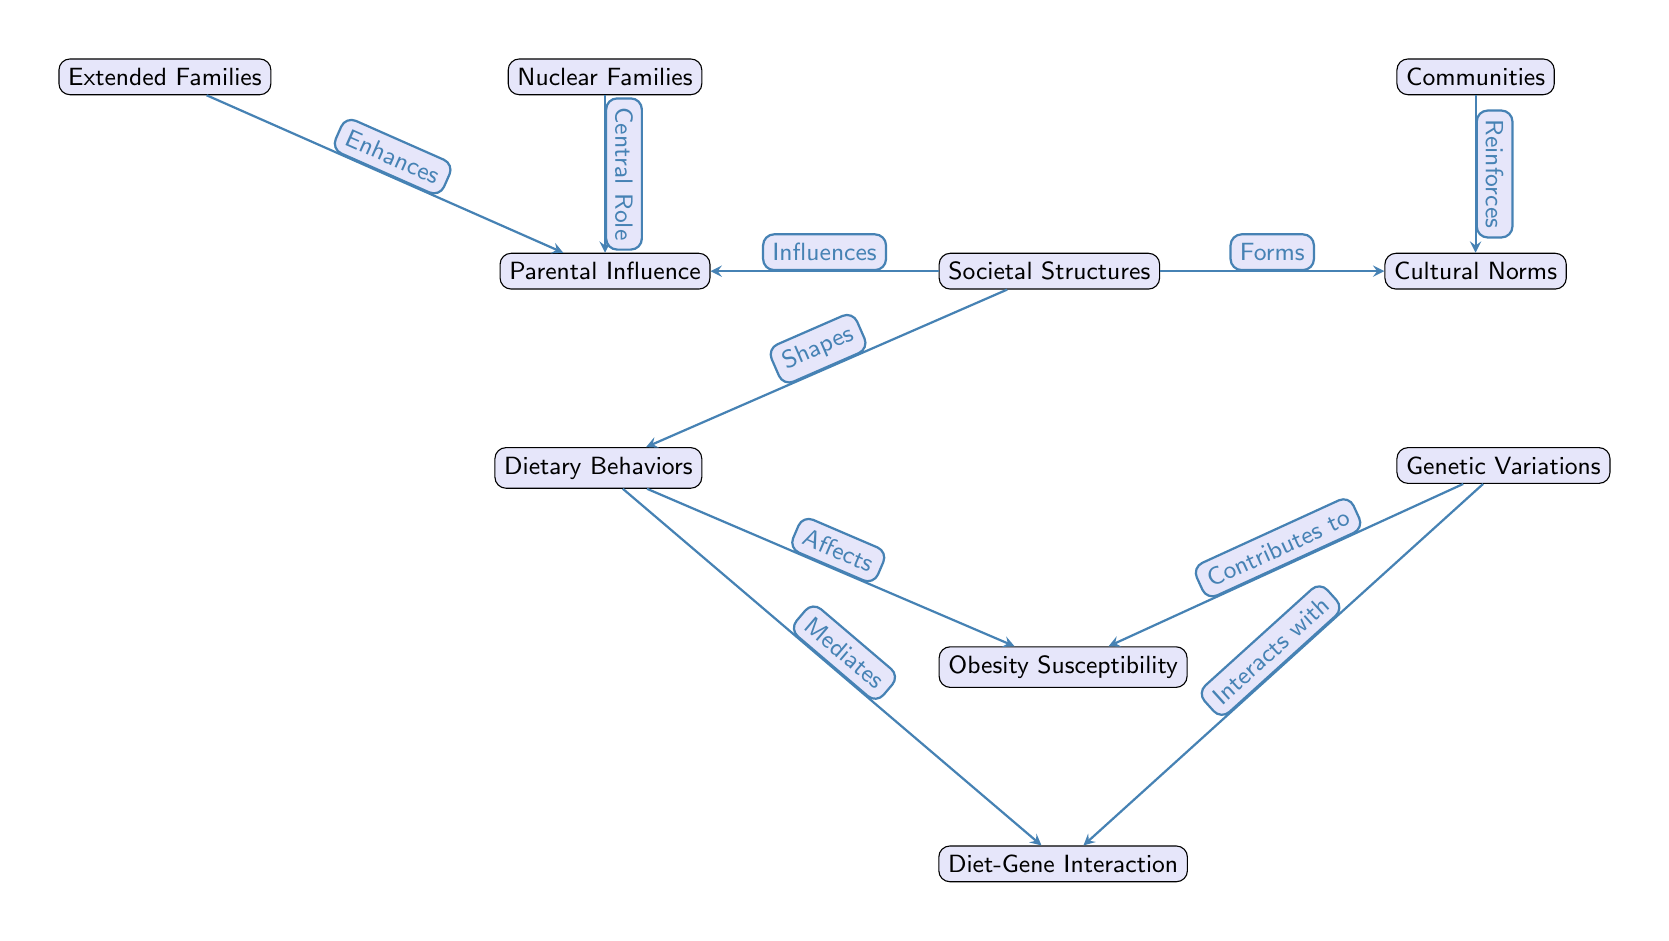What are the two main components of society represented in the diagram? The diagram includes "Dietary Behaviors" and "Genetic Variations" as the two primary components that influence societal structures.
Answer: Dietary Behaviors, Genetic Variations How many nodes are there in the diagram? By counting each labeled box, there are a total of ten nodes: Societal Structures, Dietary Behaviors, Genetic Variations, Obesity Susceptibility, Nuclear Families, Extended Families, Communities, Parental Influence, Cultural Norms, Diet-Gene Interaction.
Answer: 10 What does "Cultural Norms" reinforce in the diagram? "Cultural Norms" reinforces the influence of "Communities" on the dietary behaviors and genetic susceptibility to obesity, highlighting the social context in which these interactions occur.
Answer: Cultural Norms reinforces Communities Which node has arrows directed towards "Obesity Susceptibility"? The nodes "Dietary Behaviors" and "Genetic Variations" both have arrows pointing to "Obesity Susceptibility," indicating that both dietary habits and genetic factors contribute to the risk of obesity.
Answer: Dietary Behaviors, Genetic Variations How does "Parental Influence" relate to "Nuclear Families"? The node "Nuclear Families" has a direct relationship labeled as "Central Role" with "Parental Influence," signifying the important part that families play in shaping children's dietary habits and genetic factors leading to obesity susceptibility.
Answer: Central Role What interaction is mediated by "Dietary Behaviors"? The arrow from "Dietary Behaviors" leading to "Diet-Gene Interaction" indicates that dietary behaviors mediate how genetic variations affect obesity susceptibility, suggesting a complex interplay between diet and genetics in chronic disease development.
Answer: Mediates Diet-Gene Interaction What societal structure enhances "Parental Influence"? "Extended Families" is shown to enhance "Parental Influence," suggesting that broader family dynamics contribute positively to parenting and dietary behaviors affecting obesity susceptibility.
Answer: Extended Families How does "Genetic Variations" interact with "Diet-Gene Interaction"? There is a direct relationship where "Genetic Variations" is stated to interact with "Diet-Gene Interaction," indicating that the effects of these genetic factors will depend significantly on dietary choices, emphasizing the critical nature of this relationship in the context of obesity risk.
Answer: Interacts with Diet-Gene Interaction 